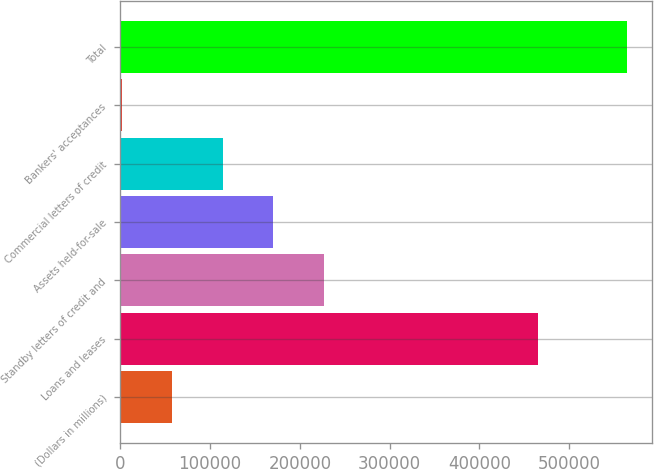Convert chart. <chart><loc_0><loc_0><loc_500><loc_500><bar_chart><fcel>(Dollars in millions)<fcel>Loans and leases<fcel>Standby letters of credit and<fcel>Assets held-for-sale<fcel>Commercial letters of credit<fcel>Bankers' acceptances<fcel>Total<nl><fcel>57887.6<fcel>464963<fcel>226618<fcel>170375<fcel>114131<fcel>1644<fcel>564080<nl></chart> 